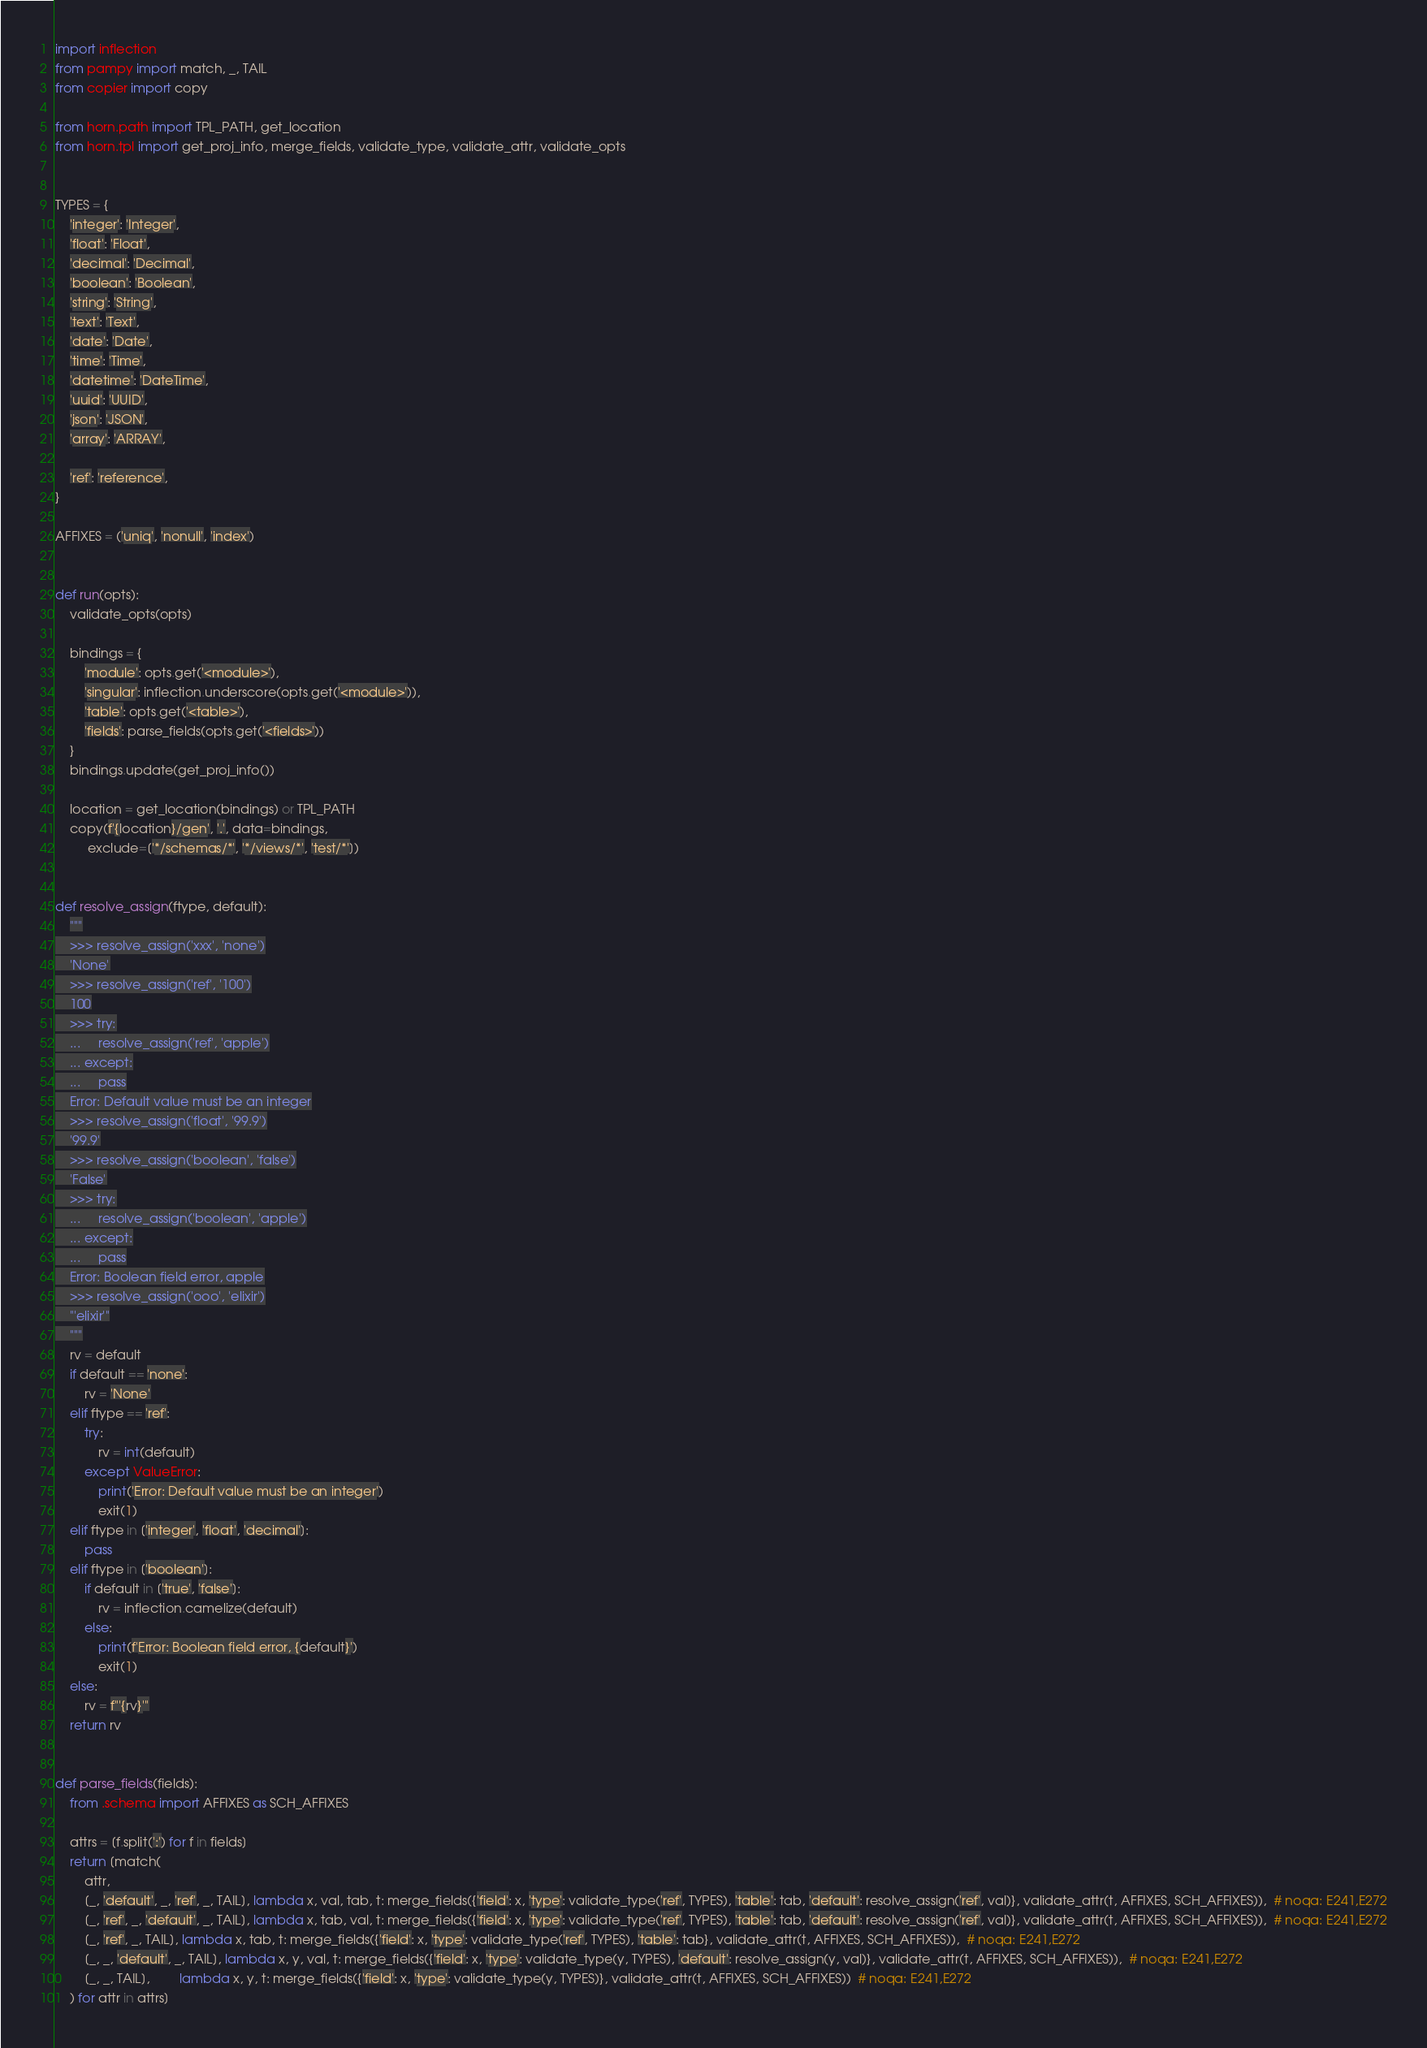<code> <loc_0><loc_0><loc_500><loc_500><_Python_>import inflection
from pampy import match, _, TAIL
from copier import copy

from horn.path import TPL_PATH, get_location
from horn.tpl import get_proj_info, merge_fields, validate_type, validate_attr, validate_opts


TYPES = {
    'integer': 'Integer',
    'float': 'Float',
    'decimal': 'Decimal',
    'boolean': 'Boolean',
    'string': 'String',
    'text': 'Text',
    'date': 'Date',
    'time': 'Time',
    'datetime': 'DateTime',
    'uuid': 'UUID',
    'json': 'JSON',
    'array': 'ARRAY',

    'ref': 'reference',
}

AFFIXES = ('uniq', 'nonull', 'index')


def run(opts):
    validate_opts(opts)

    bindings = {
        'module': opts.get('<module>'),
        'singular': inflection.underscore(opts.get('<module>')),
        'table': opts.get('<table>'),
        'fields': parse_fields(opts.get('<fields>'))
    }
    bindings.update(get_proj_info())

    location = get_location(bindings) or TPL_PATH
    copy(f'{location}/gen', '.', data=bindings,
         exclude=['*/schemas/*', '*/views/*', 'test/*'])


def resolve_assign(ftype, default):
    """
    >>> resolve_assign('xxx', 'none')
    'None'
    >>> resolve_assign('ref', '100')
    100
    >>> try:
    ...     resolve_assign('ref', 'apple')
    ... except:
    ...     pass
    Error: Default value must be an integer
    >>> resolve_assign('float', '99.9')
    '99.9'
    >>> resolve_assign('boolean', 'false')
    'False'
    >>> try:
    ...     resolve_assign('boolean', 'apple')
    ... except:
    ...     pass
    Error: Boolean field error, apple
    >>> resolve_assign('ooo', 'elixir')
    "'elixir'"
    """
    rv = default
    if default == 'none':
        rv = 'None'
    elif ftype == 'ref':
        try:
            rv = int(default)
        except ValueError:
            print('Error: Default value must be an integer')
            exit(1)
    elif ftype in ['integer', 'float', 'decimal']:
        pass
    elif ftype in ['boolean']:
        if default in ['true', 'false']:
            rv = inflection.camelize(default)
        else:
            print(f'Error: Boolean field error, {default}')
            exit(1)
    else:
        rv = f"'{rv}'"
    return rv


def parse_fields(fields):
    from .schema import AFFIXES as SCH_AFFIXES

    attrs = [f.split(':') for f in fields]
    return [match(
        attr,
        [_, 'default', _, 'ref', _, TAIL], lambda x, val, tab, t: merge_fields({'field': x, 'type': validate_type('ref', TYPES), 'table': tab, 'default': resolve_assign('ref', val)}, validate_attr(t, AFFIXES, SCH_AFFIXES)),  # noqa: E241,E272
        [_, 'ref', _, 'default', _, TAIL], lambda x, tab, val, t: merge_fields({'field': x, 'type': validate_type('ref', TYPES), 'table': tab, 'default': resolve_assign('ref', val)}, validate_attr(t, AFFIXES, SCH_AFFIXES)),  # noqa: E241,E272
        [_, 'ref', _, TAIL], lambda x, tab, t: merge_fields({'field': x, 'type': validate_type('ref', TYPES), 'table': tab}, validate_attr(t, AFFIXES, SCH_AFFIXES)),  # noqa: E241,E272
        [_, _, 'default', _, TAIL], lambda x, y, val, t: merge_fields({'field': x, 'type': validate_type(y, TYPES), 'default': resolve_assign(y, val)}, validate_attr(t, AFFIXES, SCH_AFFIXES)),  # noqa: E241,E272
        [_, _, TAIL],        lambda x, y, t: merge_fields({'field': x, 'type': validate_type(y, TYPES)}, validate_attr(t, AFFIXES, SCH_AFFIXES))  # noqa: E241,E272
    ) for attr in attrs]
</code> 